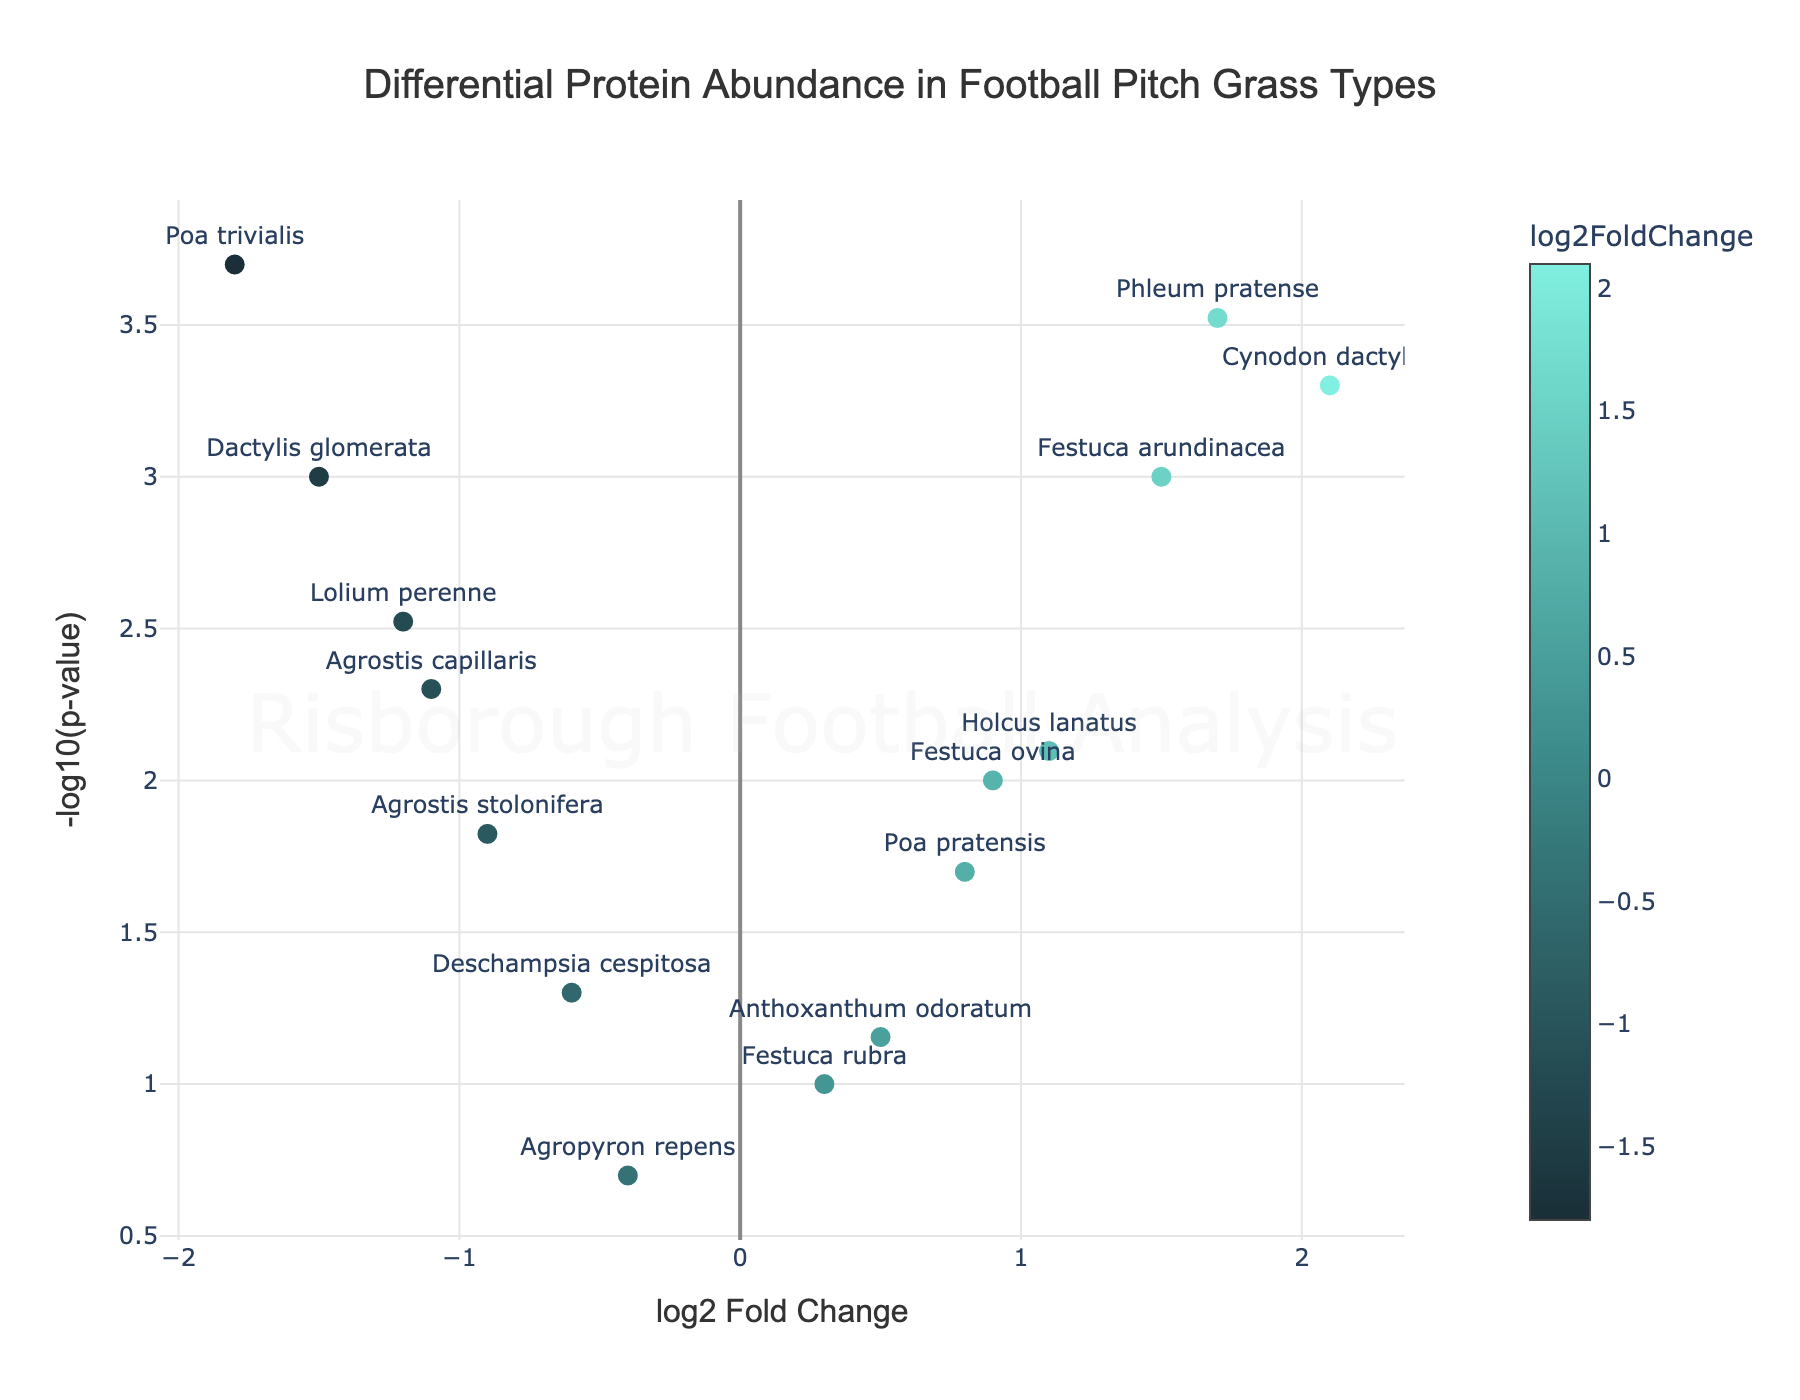How many proteins have a -log10(p-value) greater than 2? To find the number of proteins with a -log10(p-value) greater than 2, observe the y-axis (-log10(p-value)) and count the data points above the value of 2. From the plot, we identify five such points.
Answer: 5 Which protein has the highest log2 fold change? Examine the x-axis (log2 fold change) and look for the data point furthest to the right. The protein annotated at this position is Cynodon dactylon with a log2 fold change of 2.1.
Answer: Cynodon dactylon Which protein has the lowest p-value? The lowest p-value corresponds to the highest -log10(p-value). Observe the data point with the highest y-coordinate. This protein is Poa trivialis with a -log10(p-value) of 3.70.
Answer: Poa trivialis What is the log2 fold change range represented in the plot? Look at the x-axis and identify the minimum and maximum values for log2 fold change. The minimum is around -1.8 and the maximum is around 2.1. So, the log2 fold change range is from -1.8 to 2.1.
Answer: -1.8 to 2.1 For which proteins is the log2 fold change negative? Identify the proteins located on the left half of the plot (x-axis values less than 0). These proteins are Lolium perenne, Agrostis stolonifera, Poa trivialis, Dactylis glomerata, Agrostis capillaris, and Deschampsia cespitosa.
Answer: Lolium perenne, Agrostis stolonifera, Poa trivialis, Dactylis glomerata, Agrostis capillaris, Deschampsia cespitosa What is the common characteristic between Festuca arundinacea and Holcus lanatus? Both data points for Festuca arundinacea and Holcus lanatus are located on the right side of the plot (indicating positive log2 fold change) and above the y-axis value of 2 (indicating -log10(p-value) > 2).
Answer: Positive log2 fold change and -log10(p-value) > 2 Which protein is closest to the origin (0,0)? Locate the data point nearest to the origin (0, 0). Agropyron repens is the closest, with log2 fold change of -0.4 and -log10(p-value) of 0.70.
Answer: Agropyron repens What proportion of proteins have a positive log2 fold change? Count the number of proteins with a log2 fold change greater than 0 and divide by the total number of proteins. There are eight proteins with a positive log2 fold change out of a total of fourteen proteins. The proportion is approximately 8/14.
Answer: 8/14 or 57% What is the average -log10(p-value) for the proteins with positive log2 fold change? First, identify the data points with positive log2 fold change and then sum their -log10(p-value) values. The sum is approximately 14.23. Divide by the number of these proteins (8) to get the average.
Answer: 14.23 / 8 ≈ 1.78 